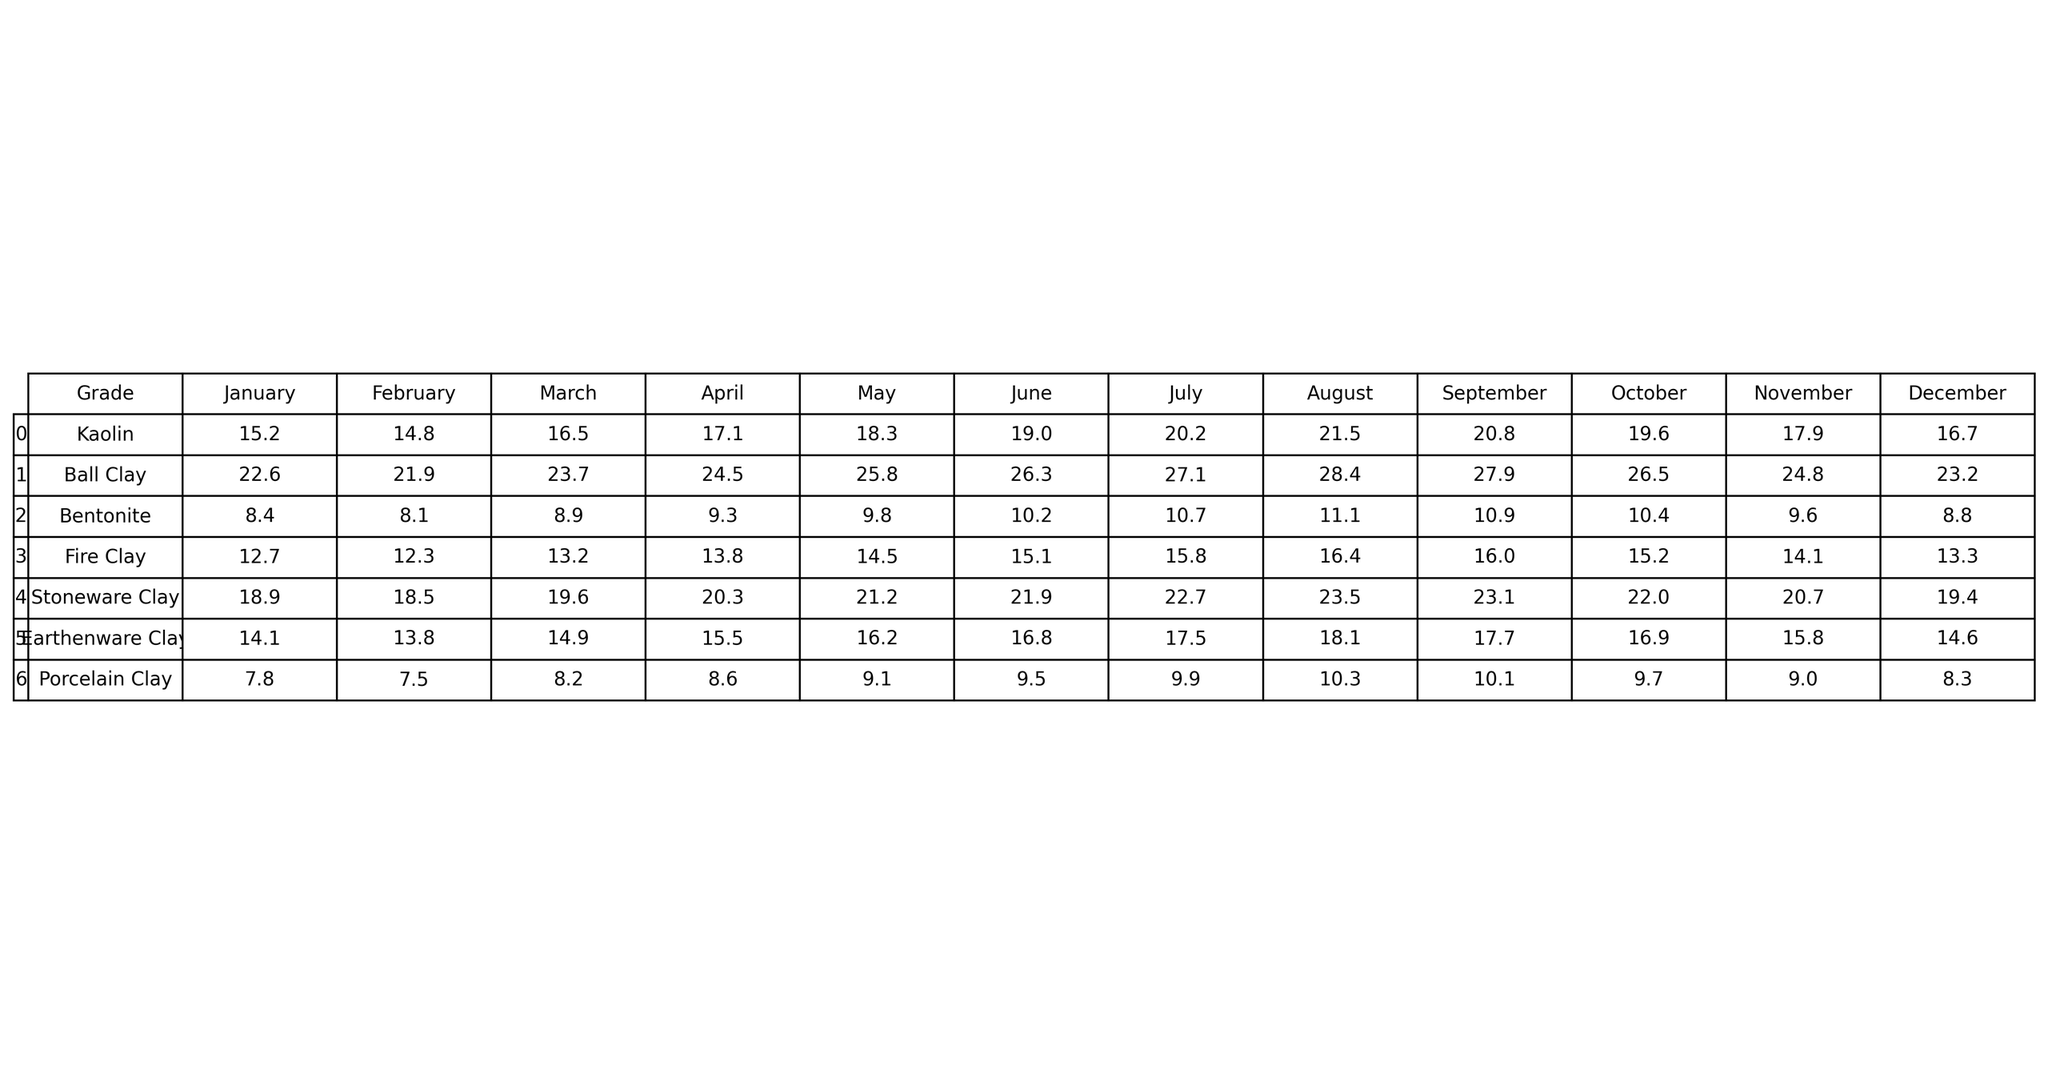What was the highest monthly production output for Kaolin? Looking at the table, the highest value in the Kaolin row is 21.5 in August.
Answer: 21.5 What is the total production output of Ball Clay for the year? To find the total output, add the monthly values: 22.6 + 21.9 + 23.7 + 24.5 + 25.8 + 26.3 + 27.1 + 28.4 + 27.9 + 26.5 + 24.8 + 23.2 = 303.6.
Answer: 303.6 Which clay type had the lowest production output in October? In the October column, the lowest value is 7.8 for Porcelain Clay.
Answer: 7.8 Was the production of Stoneware Clay ever below 20 in any month? Observing the Stoneware Clay row, the values for every month are above 20.
Answer: No What was the average production output for Fire Clay over the year? Calculate the average by summing monthly outputs: (12.7 + 12.3 + 13.2 + 13.8 + 14.5 + 15.1 + 15.8 + 16.4 + 16.0 + 15.2 + 14.1 + 13.3) = 171.2, then divide by 12: 171.2 / 12 = 14.27.
Answer: 14.27 Which month had the highest production output for Earthenware Clay and what was the output? The highest value for Earthenware Clay is 18.1 in August.
Answer: 18.1 Is the production output of Bentonite increasing consistently each month? Checking the Bentonite row reveals that the values increase except for a decrease from 10.9 in September to 10.4 in October.
Answer: No What is the difference in production output between the highest and lowest months for Porcelain Clay? The highest for Porcelain Clay is 10.3 in August and the lowest is 7.5 in February, so the difference is 10.3 - 7.5 = 2.8.
Answer: 2.8 Which clay type shows the greatest overall increase in production output from January to December? By checking the last values of each clay type, Ball Clay starts at 22.6 in January and ends at 23.2 in December, while other types show smaller increases or decreases, confirming Ball Clay as the greatest overall increase.
Answer: Ball Clay What is the production output trend for Kaolin from January to December? Observing the Kaolin row, it starts at 15.2 in January and generally increases each month, peaking at 21.5 in August before falling back to 16.7 in December, indicating an overall upward trend with fluctuations.
Answer: Generally increasing with fluctuations 